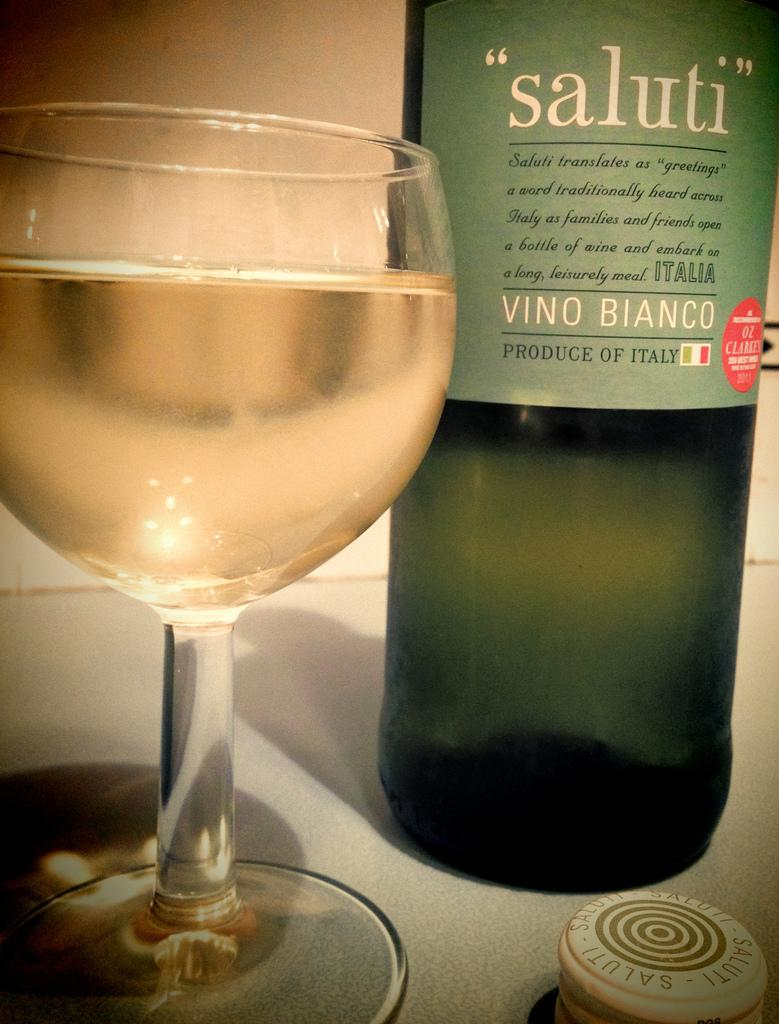What type of beverage is associated with the bottle in the image? There is a wine bottle in the image. What type of glassware is present in the image? There is a wine glass in the image. What type of harmony can be heard coming from the flowers in the image? There are no flowers present in the image, and therefore no harmony can be heard. 